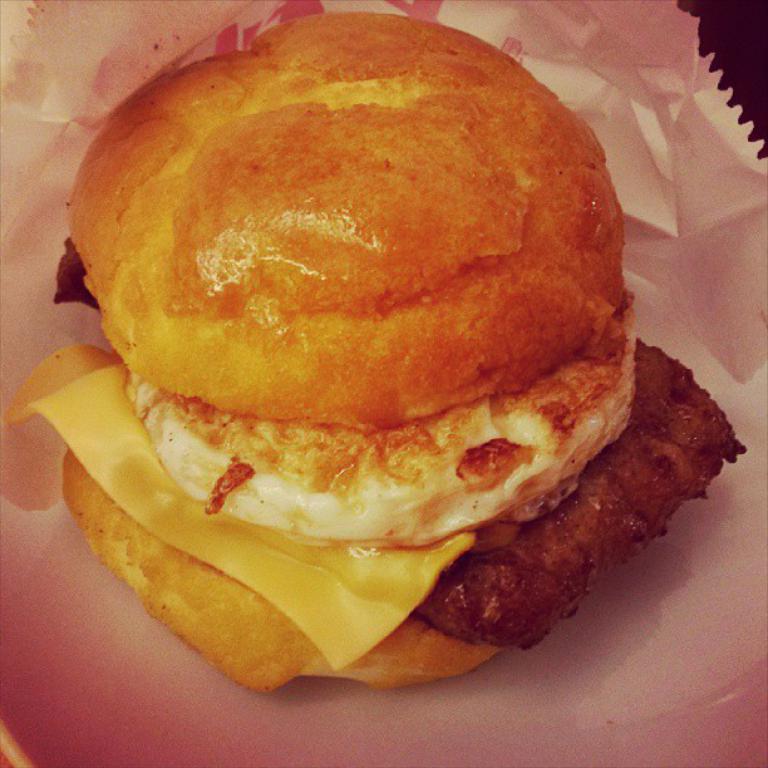Describe this image in one or two sentences. In this picture there is a burger on the paper. On the top right corner there is a table. 